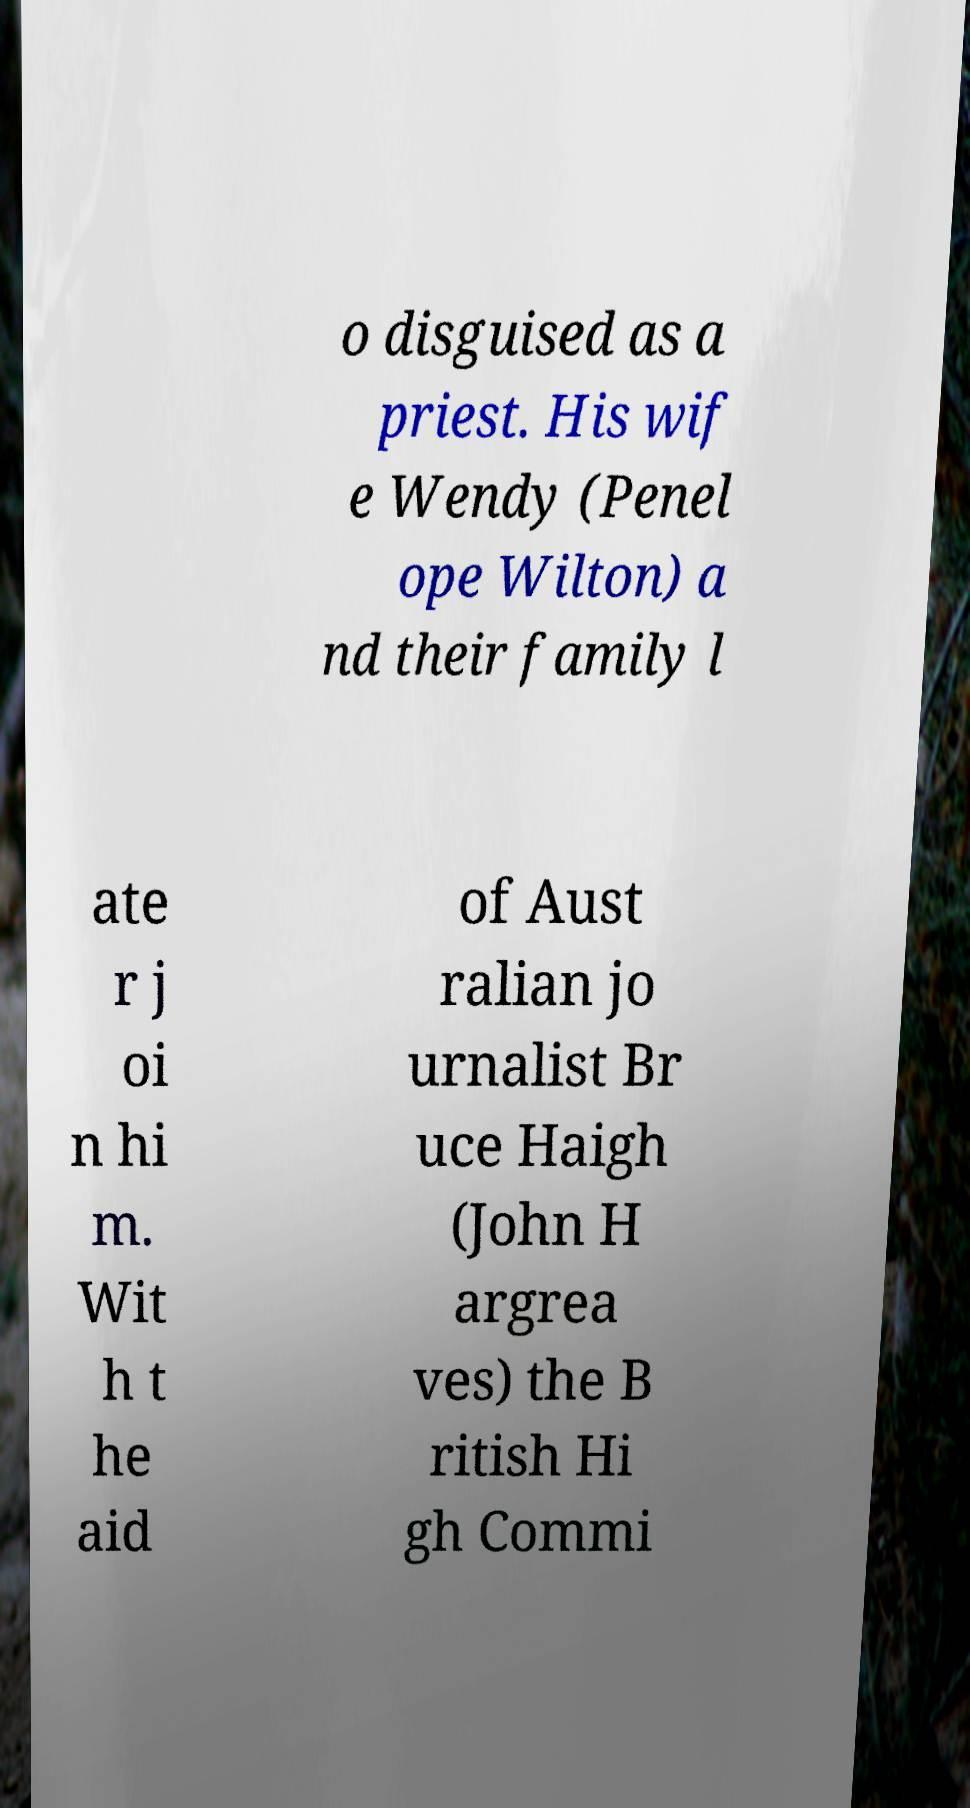For documentation purposes, I need the text within this image transcribed. Could you provide that? o disguised as a priest. His wif e Wendy (Penel ope Wilton) a nd their family l ate r j oi n hi m. Wit h t he aid of Aust ralian jo urnalist Br uce Haigh (John H argrea ves) the B ritish Hi gh Commi 